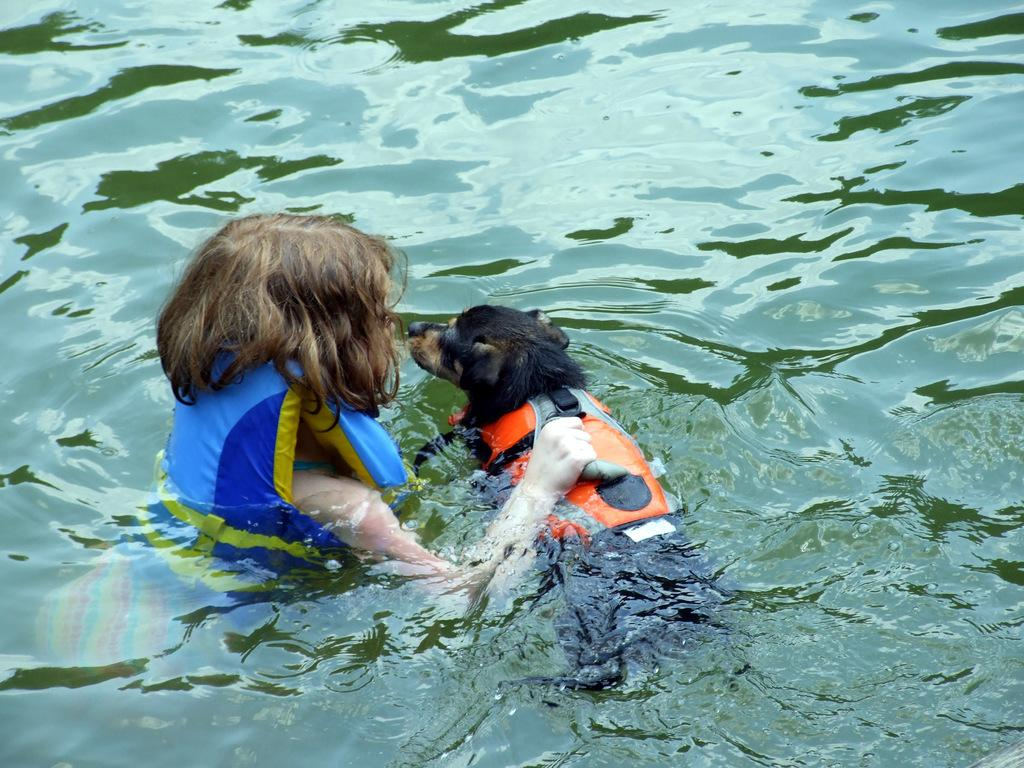Who or what is present in the image? There is a person and a dog in the image. What is the setting or environment in which they are located? Both the person and the dog are in the water. Where is the house located in the image? There is no house present in the image; it features a person and a dog in the water. What type of argument can be seen taking place between the person and the dog in the image? There is no argument present in the image; it features a person and a dog in the water. 